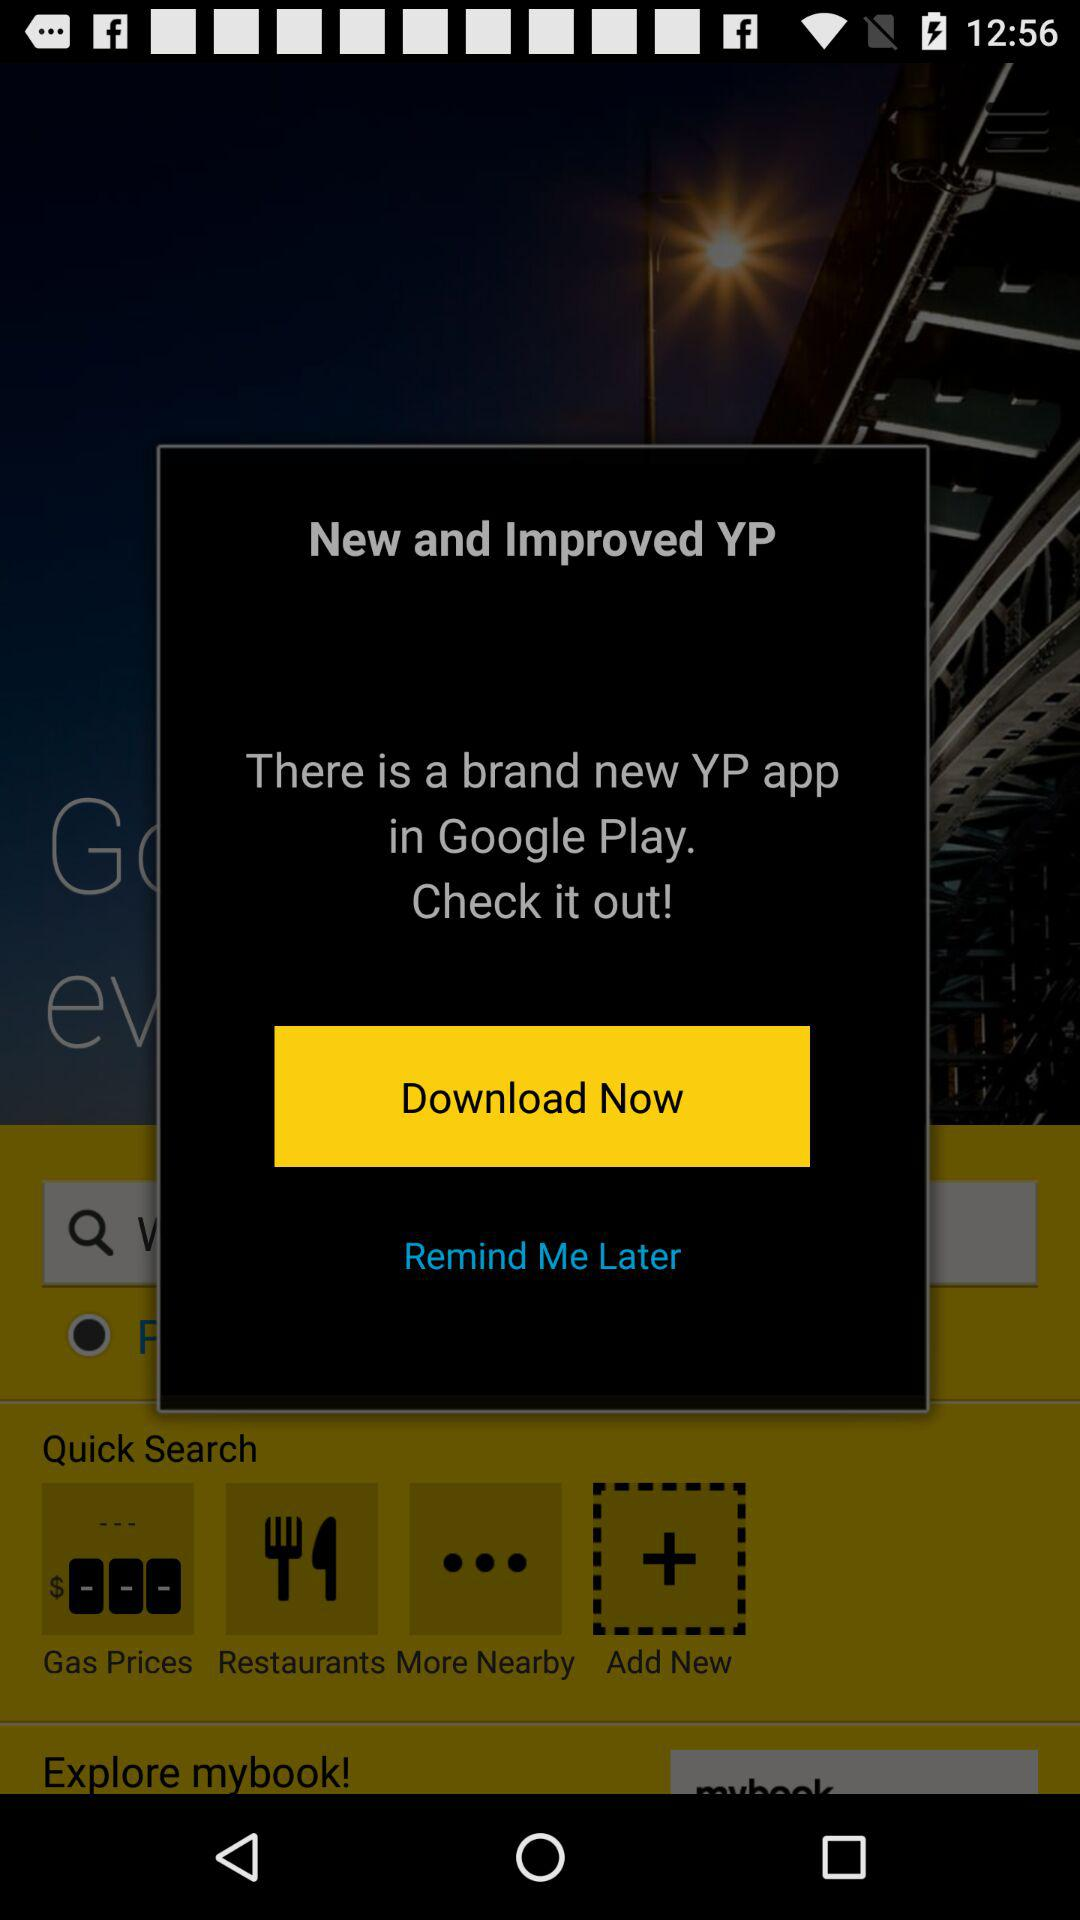What is the app name? The app name is "YP". 